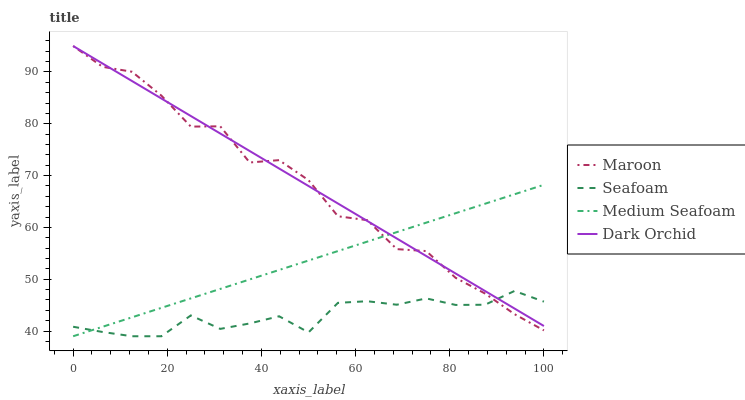Does Seafoam have the minimum area under the curve?
Answer yes or no. Yes. Does Dark Orchid have the maximum area under the curve?
Answer yes or no. Yes. Does Maroon have the minimum area under the curve?
Answer yes or no. No. Does Maroon have the maximum area under the curve?
Answer yes or no. No. Is Dark Orchid the smoothest?
Answer yes or no. Yes. Is Maroon the roughest?
Answer yes or no. Yes. Is Seafoam the smoothest?
Answer yes or no. No. Is Seafoam the roughest?
Answer yes or no. No. Does Seafoam have the lowest value?
Answer yes or no. Yes. Does Maroon have the lowest value?
Answer yes or no. No. Does Maroon have the highest value?
Answer yes or no. Yes. Does Seafoam have the highest value?
Answer yes or no. No. Does Dark Orchid intersect Maroon?
Answer yes or no. Yes. Is Dark Orchid less than Maroon?
Answer yes or no. No. Is Dark Orchid greater than Maroon?
Answer yes or no. No. 